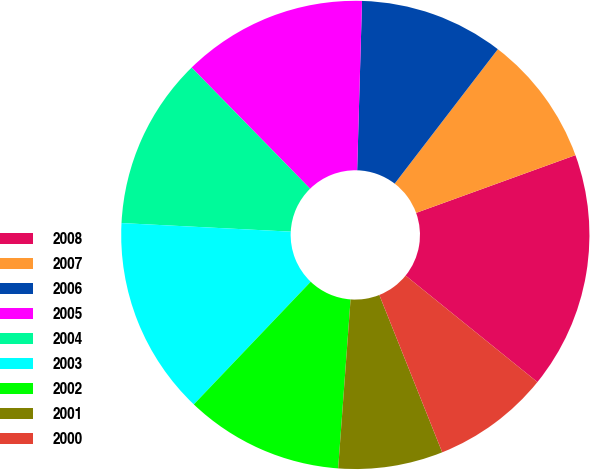Convert chart. <chart><loc_0><loc_0><loc_500><loc_500><pie_chart><fcel>2008<fcel>2007<fcel>2006<fcel>2005<fcel>2004<fcel>2003<fcel>2002<fcel>2001<fcel>2000<nl><fcel>16.35%<fcel>9.05%<fcel>9.96%<fcel>12.78%<fcel>11.87%<fcel>13.69%<fcel>10.95%<fcel>7.22%<fcel>8.13%<nl></chart> 